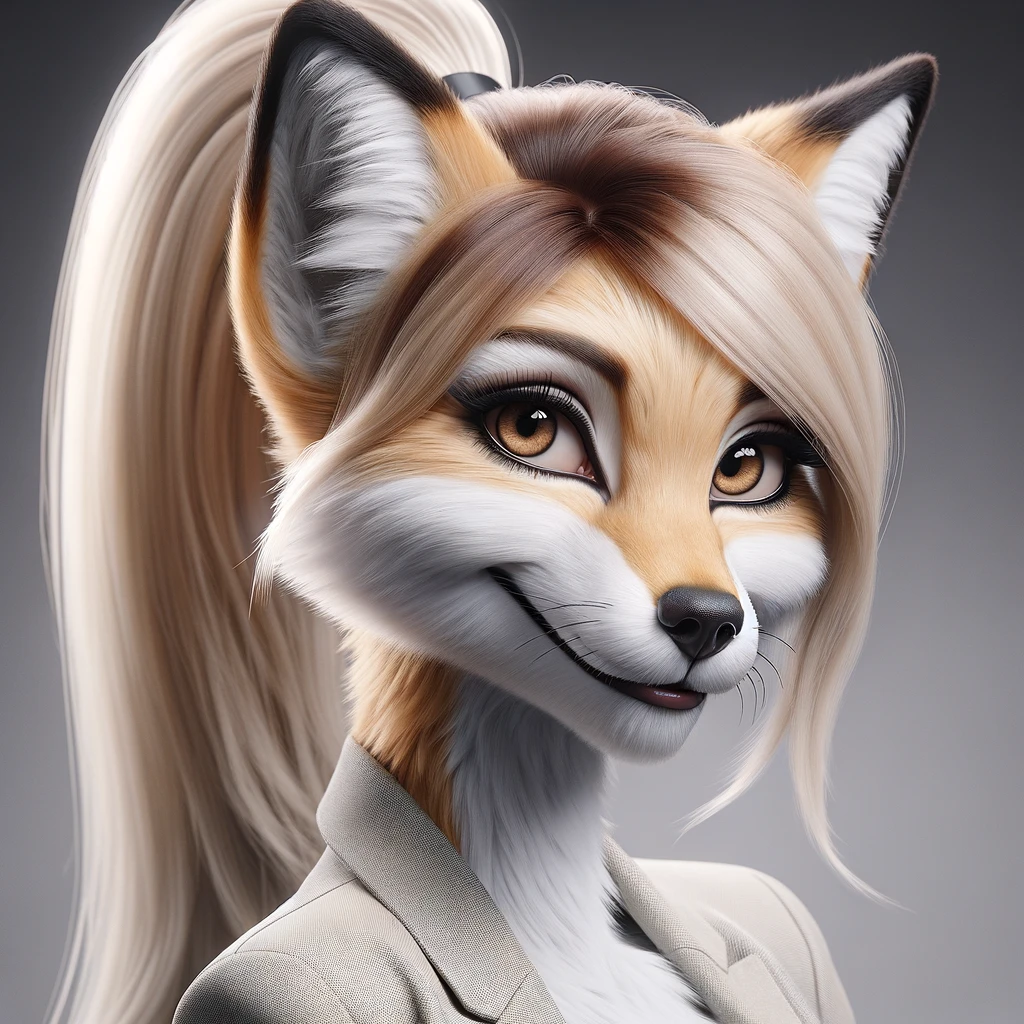describe this image The image is a 3D rendering of a cartoon fox. The fox is wearing a white button-down shirt and has a ponytail. The fox has brown fur and green eyes. 